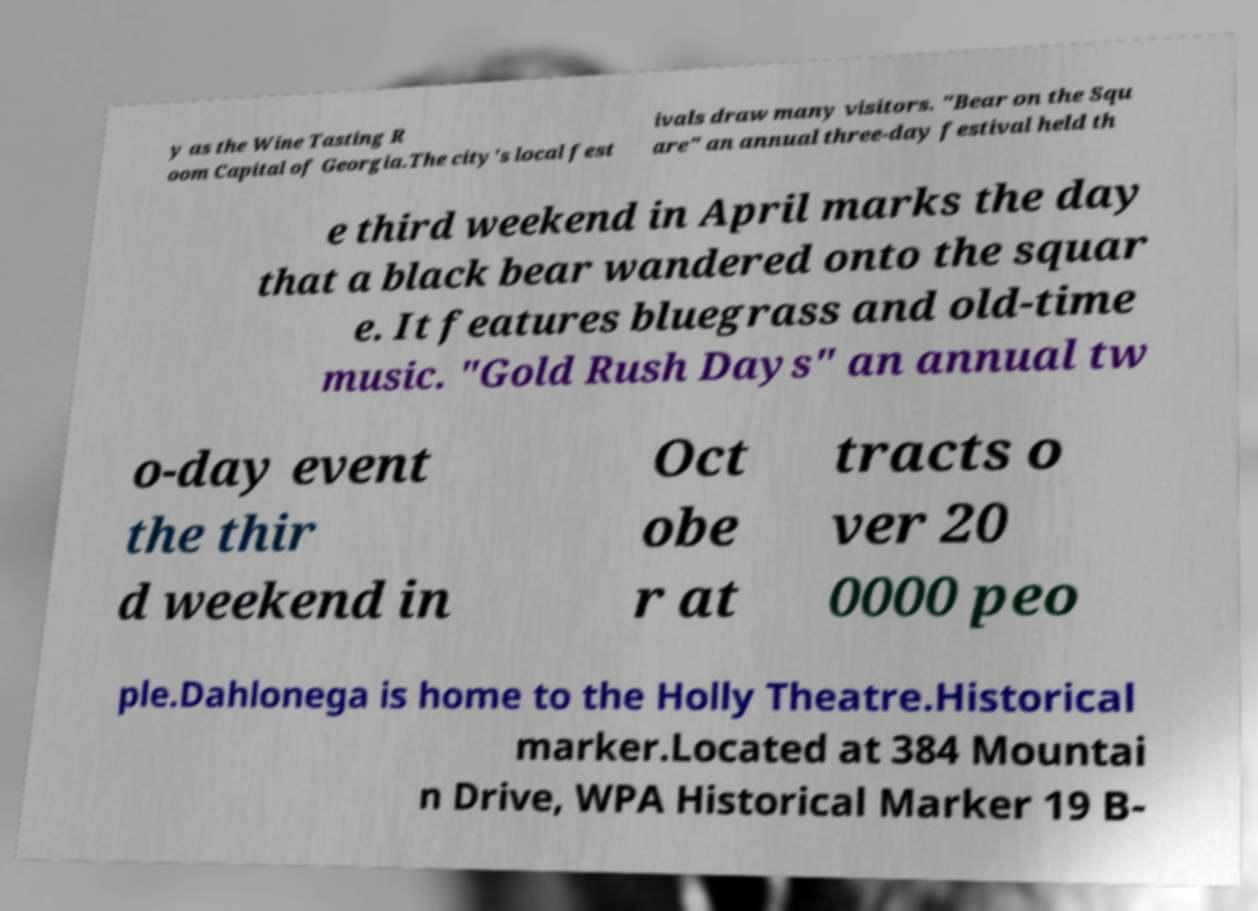I need the written content from this picture converted into text. Can you do that? y as the Wine Tasting R oom Capital of Georgia.The city's local fest ivals draw many visitors. "Bear on the Squ are" an annual three-day festival held th e third weekend in April marks the day that a black bear wandered onto the squar e. It features bluegrass and old-time music. "Gold Rush Days" an annual tw o-day event the thir d weekend in Oct obe r at tracts o ver 20 0000 peo ple.Dahlonega is home to the Holly Theatre.Historical marker.Located at 384 Mountai n Drive, WPA Historical Marker 19 B- 